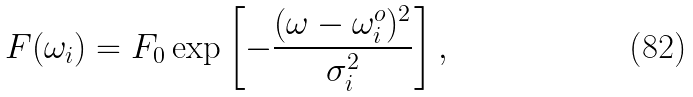<formula> <loc_0><loc_0><loc_500><loc_500>F ( \omega _ { i } ) = F _ { 0 } \exp \left [ - \frac { ( \omega - \omega ^ { o } _ { i } ) ^ { 2 } } { \sigma _ { i } ^ { 2 } } \right ] ,</formula> 